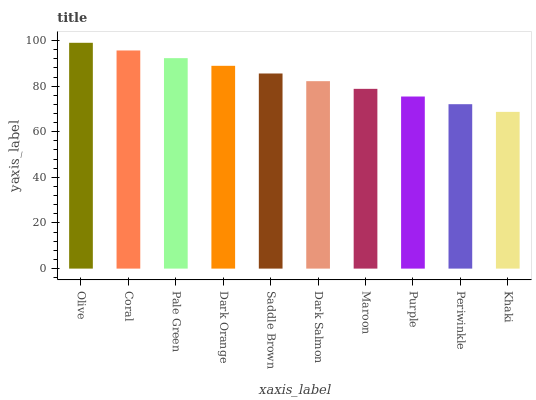Is Khaki the minimum?
Answer yes or no. Yes. Is Olive the maximum?
Answer yes or no. Yes. Is Coral the minimum?
Answer yes or no. No. Is Coral the maximum?
Answer yes or no. No. Is Olive greater than Coral?
Answer yes or no. Yes. Is Coral less than Olive?
Answer yes or no. Yes. Is Coral greater than Olive?
Answer yes or no. No. Is Olive less than Coral?
Answer yes or no. No. Is Saddle Brown the high median?
Answer yes or no. Yes. Is Dark Salmon the low median?
Answer yes or no. Yes. Is Khaki the high median?
Answer yes or no. No. Is Saddle Brown the low median?
Answer yes or no. No. 